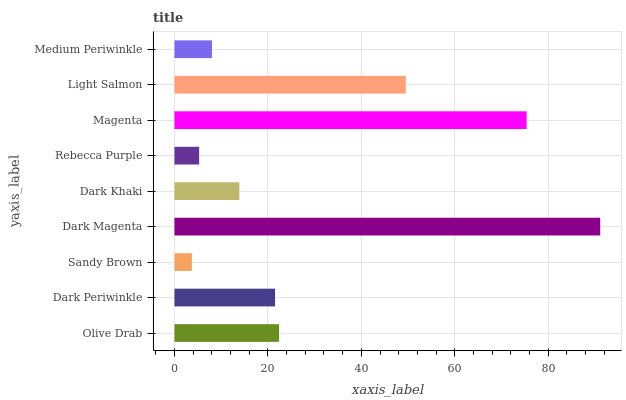Is Sandy Brown the minimum?
Answer yes or no. Yes. Is Dark Magenta the maximum?
Answer yes or no. Yes. Is Dark Periwinkle the minimum?
Answer yes or no. No. Is Dark Periwinkle the maximum?
Answer yes or no. No. Is Olive Drab greater than Dark Periwinkle?
Answer yes or no. Yes. Is Dark Periwinkle less than Olive Drab?
Answer yes or no. Yes. Is Dark Periwinkle greater than Olive Drab?
Answer yes or no. No. Is Olive Drab less than Dark Periwinkle?
Answer yes or no. No. Is Dark Periwinkle the high median?
Answer yes or no. Yes. Is Dark Periwinkle the low median?
Answer yes or no. Yes. Is Magenta the high median?
Answer yes or no. No. Is Olive Drab the low median?
Answer yes or no. No. 